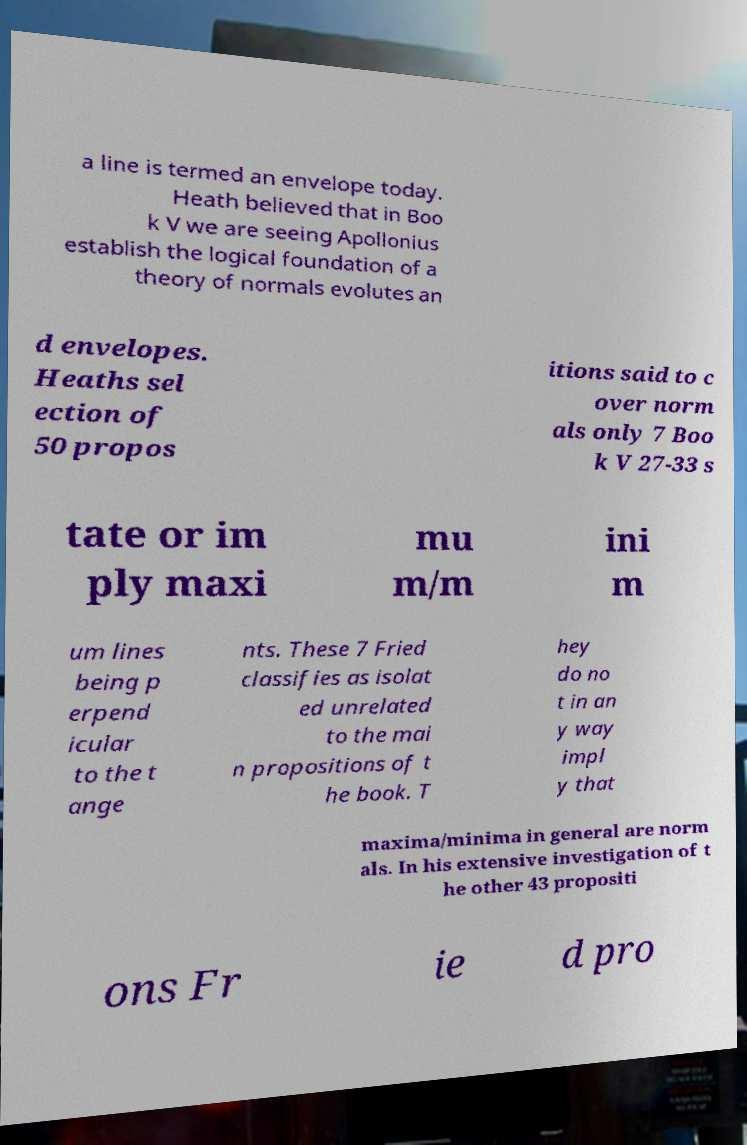Could you assist in decoding the text presented in this image and type it out clearly? a line is termed an envelope today. Heath believed that in Boo k V we are seeing Apollonius establish the logical foundation of a theory of normals evolutes an d envelopes. Heaths sel ection of 50 propos itions said to c over norm als only 7 Boo k V 27-33 s tate or im ply maxi mu m/m ini m um lines being p erpend icular to the t ange nts. These 7 Fried classifies as isolat ed unrelated to the mai n propositions of t he book. T hey do no t in an y way impl y that maxima/minima in general are norm als. In his extensive investigation of t he other 43 propositi ons Fr ie d pro 